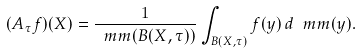<formula> <loc_0><loc_0><loc_500><loc_500>( A _ { \tau } f ) ( X ) = \frac { 1 } { \ m m ( B ( X , \tau ) ) } \int _ { B ( X , \tau ) } f ( y ) \, d \ m m ( y ) .</formula> 